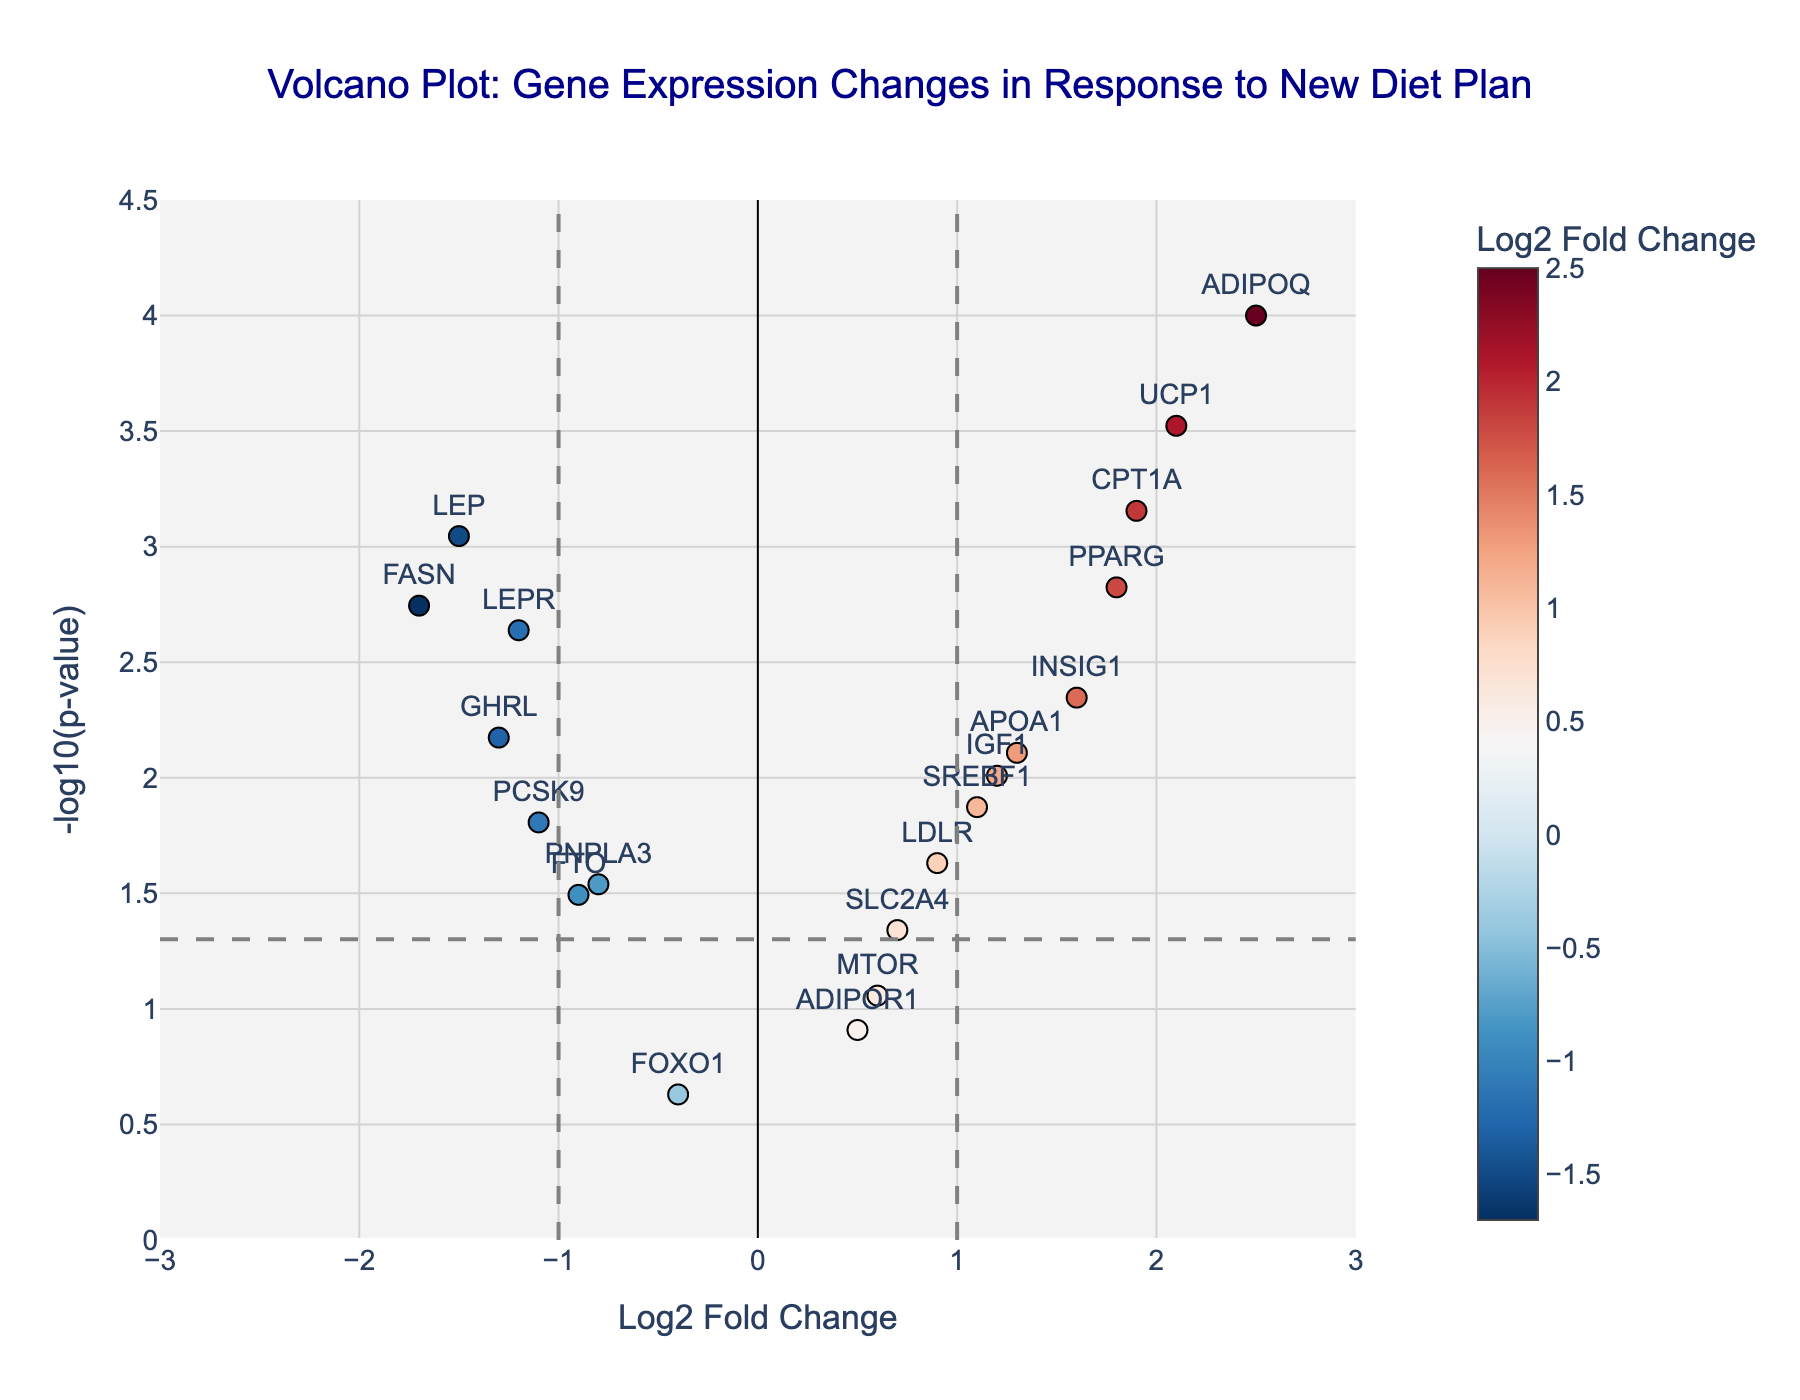What's the title of the plot? The title is usually found at the top of the plot. In this case, it reads "Volcano Plot: Gene Expression Changes in Response to New Diet Plan".
Answer: Volcano Plot: Gene Expression Changes in Response to New Diet Plan Which gene has the highest -log10(p-value)? Check the y-axis (-log10(p-value)) for the highest point, then refer to the gene label at the top of that point.
Answer: ADIPOQ How many genes have a significant p-value threshold below 0.05 and a log2 fold change greater than 1? Identify genes above the horizontal line (-log10(0.05)) representing the p-value threshold of 0.05, then count those with x-values (log2 fold change) greater than 1.
Answer: 4 Which gene has the largest negative log2 fold change? Locate the point farthest to the left on the x-axis (log2 fold change) and refer to the gene label at that point.
Answer: FASN What is the log2 fold change and p-value of the gene INSIG1? Hover over or look at the point labeled "INSIG1", checking its coordinates and hover text box to get the respective values.
Answer: Log2 Fold Change: 1.6, P-value: 0.0045 Compare the log2 fold change between LEP and UCP1. Which has a higher value? Locate both genes on the plot, compare their positions on the x-axis (log2 fold change), and see which is further right.
Answer: UCP1 Which gene closest to the center (0) on the log2 fold change scale also has a p-value below 0.05? Find the gene points around the x-axis value of 0 and check if their y-axis values are above the p-value threshold line.
Answer: SLC2A4 How many genes showed a log2 fold change of less than -1? Locate points to the left of the vertical line at -1 on the x-axis and count them.
Answer: 3 What is the -log10(p-value) threshold line value? The horizontal line signifies the significance cutoff which is -log10(0.05).
Answer: 1.3 